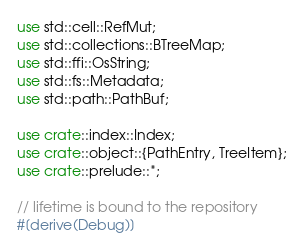<code> <loc_0><loc_0><loc_500><loc_500><_Rust_>use std::cell::RefMut;
use std::collections::BTreeMap;
use std::ffi::OsString;
use std::fs::Metadata;
use std::path::PathBuf;

use crate::index::Index;
use crate::object::{PathEntry, TreeItem};
use crate::prelude::*;

// lifetime is bound to the repository
#[derive(Debug)]</code> 